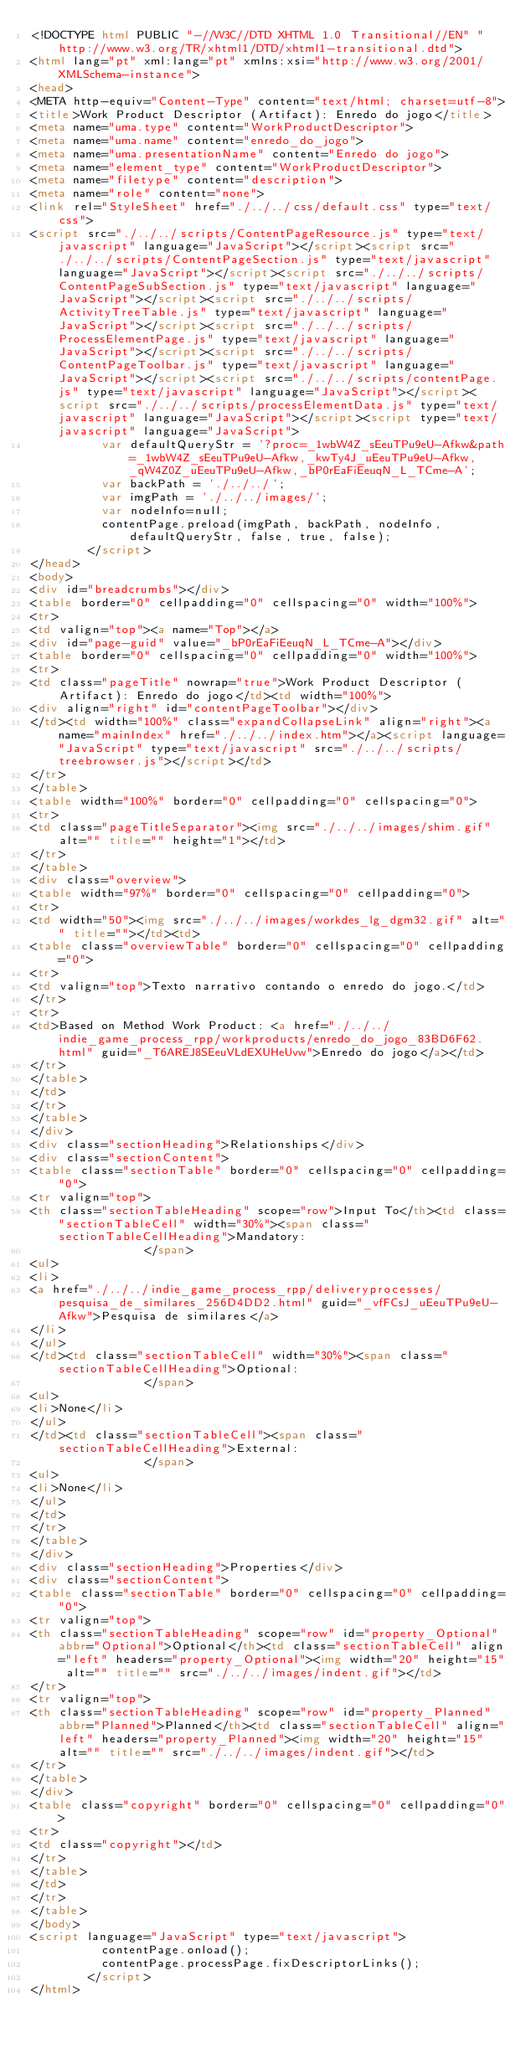<code> <loc_0><loc_0><loc_500><loc_500><_HTML_><!DOCTYPE html PUBLIC "-//W3C//DTD XHTML 1.0 Transitional//EN" "http://www.w3.org/TR/xhtml1/DTD/xhtml1-transitional.dtd">
<html lang="pt" xml:lang="pt" xmlns:xsi="http://www.w3.org/2001/XMLSchema-instance">
<head>
<META http-equiv="Content-Type" content="text/html; charset=utf-8">
<title>Work Product Descriptor (Artifact): Enredo do jogo</title>
<meta name="uma.type" content="WorkProductDescriptor">
<meta name="uma.name" content="enredo_do_jogo">
<meta name="uma.presentationName" content="Enredo do jogo">
<meta name="element_type" content="WorkProductDescriptor">
<meta name="filetype" content="description">
<meta name="role" content="none">
<link rel="StyleSheet" href="./../../css/default.css" type="text/css">
<script src="./../../scripts/ContentPageResource.js" type="text/javascript" language="JavaScript"></script><script src="./../../scripts/ContentPageSection.js" type="text/javascript" language="JavaScript"></script><script src="./../../scripts/ContentPageSubSection.js" type="text/javascript" language="JavaScript"></script><script src="./../../scripts/ActivityTreeTable.js" type="text/javascript" language="JavaScript"></script><script src="./../../scripts/ProcessElementPage.js" type="text/javascript" language="JavaScript"></script><script src="./../../scripts/ContentPageToolbar.js" type="text/javascript" language="JavaScript"></script><script src="./../../scripts/contentPage.js" type="text/javascript" language="JavaScript"></script><script src="./../../scripts/processElementData.js" type="text/javascript" language="JavaScript"></script><script type="text/javascript" language="JavaScript">
					var defaultQueryStr = '?proc=_1wbW4Z_sEeuTPu9eU-Afkw&path=_1wbW4Z_sEeuTPu9eU-Afkw,_kwTy4J_uEeuTPu9eU-Afkw,_qW4Z0Z_uEeuTPu9eU-Afkw,_bP0rEaFiEeuqN_L_TCme-A';
					var backPath = './../../';
					var imgPath = './../../images/';
					var nodeInfo=null;
					contentPage.preload(imgPath, backPath, nodeInfo, defaultQueryStr, false, true, false);
				</script>
</head>
<body>
<div id="breadcrumbs"></div>
<table border="0" cellpadding="0" cellspacing="0" width="100%">
<tr>
<td valign="top"><a name="Top"></a>
<div id="page-guid" value="_bP0rEaFiEeuqN_L_TCme-A"></div>
<table border="0" cellspacing="0" cellpadding="0" width="100%">
<tr>
<td class="pageTitle" nowrap="true">Work Product Descriptor (Artifact): Enredo do jogo</td><td width="100%">
<div align="right" id="contentPageToolbar"></div>
</td><td width="100%" class="expandCollapseLink" align="right"><a name="mainIndex" href="./../../index.htm"></a><script language="JavaScript" type="text/javascript" src="./../../scripts/treebrowser.js"></script></td>
</tr>
</table>
<table width="100%" border="0" cellpadding="0" cellspacing="0">
<tr>
<td class="pageTitleSeparator"><img src="./../../images/shim.gif" alt="" title="" height="1"></td>
</tr>
</table>
<div class="overview">
<table width="97%" border="0" cellspacing="0" cellpadding="0">
<tr>
<td width="50"><img src="./../../images/workdes_lg_dgm32.gif" alt="" title=""></td><td>
<table class="overviewTable" border="0" cellspacing="0" cellpadding="0">
<tr>
<td valign="top">Texto narrativo contando o enredo do jogo.</td>
</tr>
<tr>
<td>Based on Method Work Product: <a href="./../../indie_game_process_rpp/workproducts/enredo_do_jogo_83BD6F62.html" guid="_T6AREJ8SEeuVLdEXUHeUvw">Enredo do jogo</a></td>
</tr>
</table>
</td>
</tr>
</table>
</div>
<div class="sectionHeading">Relationships</div>
<div class="sectionContent">
<table class="sectionTable" border="0" cellspacing="0" cellpadding="0">
<tr valign="top">
<th class="sectionTableHeading" scope="row">Input To</th><td class="sectionTableCell" width="30%"><span class="sectionTableCellHeading">Mandatory:
								</span>
<ul>
<li>
<a href="./../../indie_game_process_rpp/deliveryprocesses/pesquisa_de_similares_256D4DD2.html" guid="_vfFCsJ_uEeuTPu9eU-Afkw">Pesquisa de similares</a>
</li>
</ul>
</td><td class="sectionTableCell" width="30%"><span class="sectionTableCellHeading">Optional:
								</span>
<ul>
<li>None</li>
</ul>
</td><td class="sectionTableCell"><span class="sectionTableCellHeading">External:
								</span>
<ul>
<li>None</li>
</ul>
</td>
</tr>
</table>
</div>
<div class="sectionHeading">Properties</div>
<div class="sectionContent">
<table class="sectionTable" border="0" cellspacing="0" cellpadding="0">
<tr valign="top">
<th class="sectionTableHeading" scope="row" id="property_Optional" abbr="Optional">Optional</th><td class="sectionTableCell" align="left" headers="property_Optional"><img width="20" height="15" alt="" title="" src="./../../images/indent.gif"></td>
</tr>
<tr valign="top">
<th class="sectionTableHeading" scope="row" id="property_Planned" abbr="Planned">Planned</th><td class="sectionTableCell" align="left" headers="property_Planned"><img width="20" height="15" alt="" title="" src="./../../images/indent.gif"></td>
</tr>
</table>
</div>
<table class="copyright" border="0" cellspacing="0" cellpadding="0">
<tr>
<td class="copyright"></td>
</tr>
</table>
</td>
</tr>
</table>
</body>
<script language="JavaScript" type="text/javascript">
					contentPage.onload();
					contentPage.processPage.fixDescriptorLinks();
				</script>
</html>
</code> 